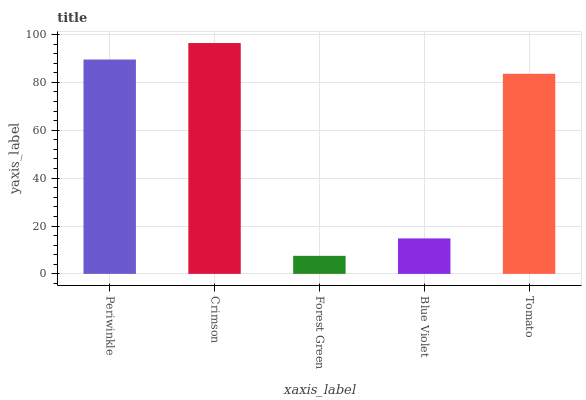Is Forest Green the minimum?
Answer yes or no. Yes. Is Crimson the maximum?
Answer yes or no. Yes. Is Crimson the minimum?
Answer yes or no. No. Is Forest Green the maximum?
Answer yes or no. No. Is Crimson greater than Forest Green?
Answer yes or no. Yes. Is Forest Green less than Crimson?
Answer yes or no. Yes. Is Forest Green greater than Crimson?
Answer yes or no. No. Is Crimson less than Forest Green?
Answer yes or no. No. Is Tomato the high median?
Answer yes or no. Yes. Is Tomato the low median?
Answer yes or no. Yes. Is Blue Violet the high median?
Answer yes or no. No. Is Crimson the low median?
Answer yes or no. No. 